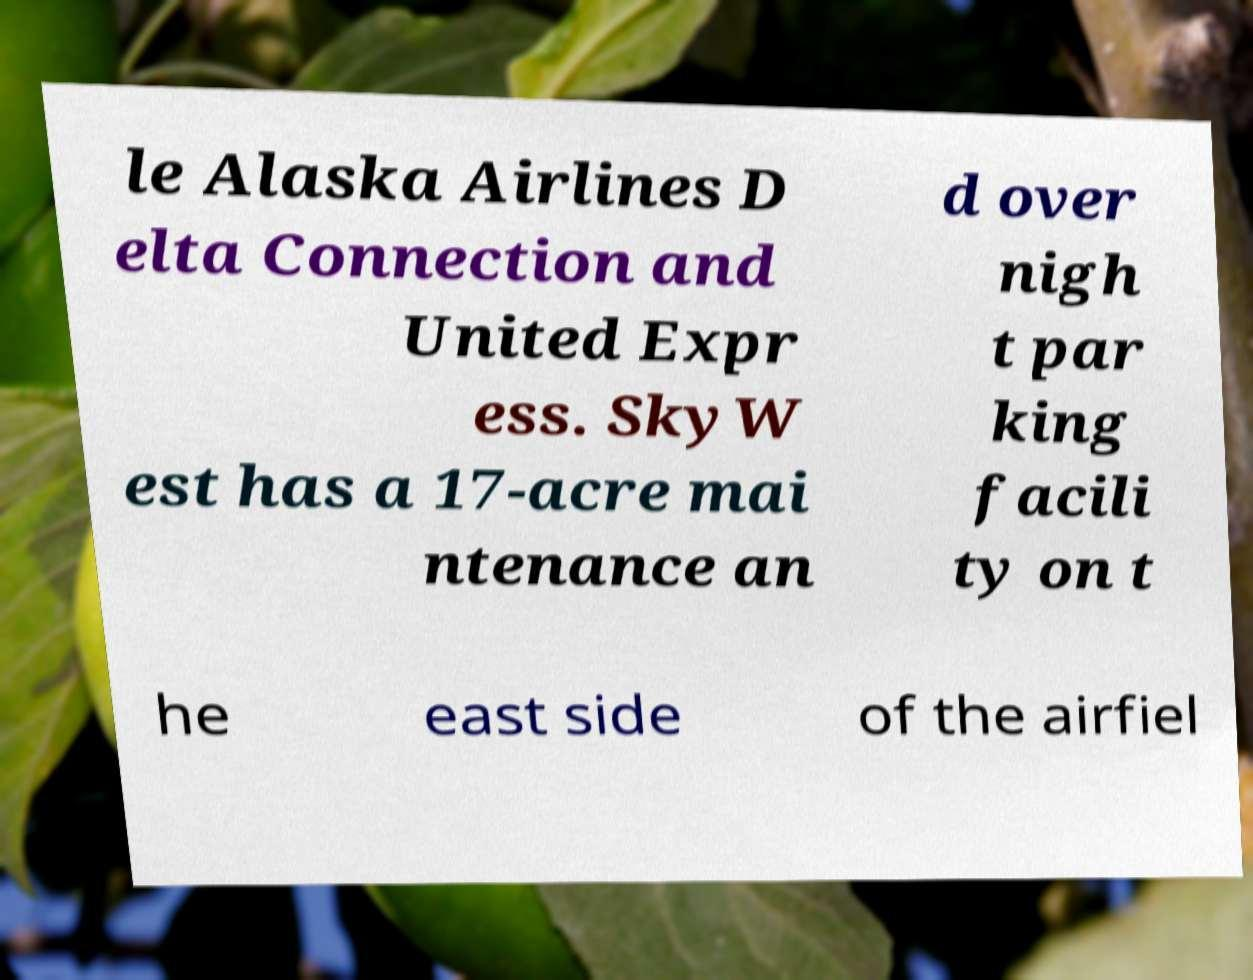What messages or text are displayed in this image? I need them in a readable, typed format. le Alaska Airlines D elta Connection and United Expr ess. SkyW est has a 17-acre mai ntenance an d over nigh t par king facili ty on t he east side of the airfiel 